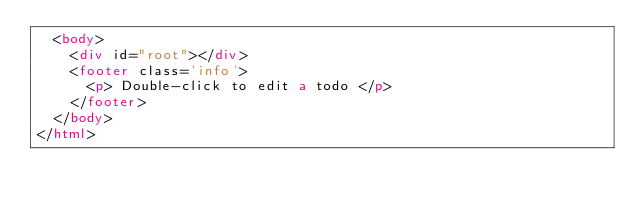Convert code to text. <code><loc_0><loc_0><loc_500><loc_500><_HTML_>  <body>
    <div id="root"></div>
    <footer class='info'>
      <p> Double-click to edit a todo </p>
    </footer>
  </body>
</html>
</code> 